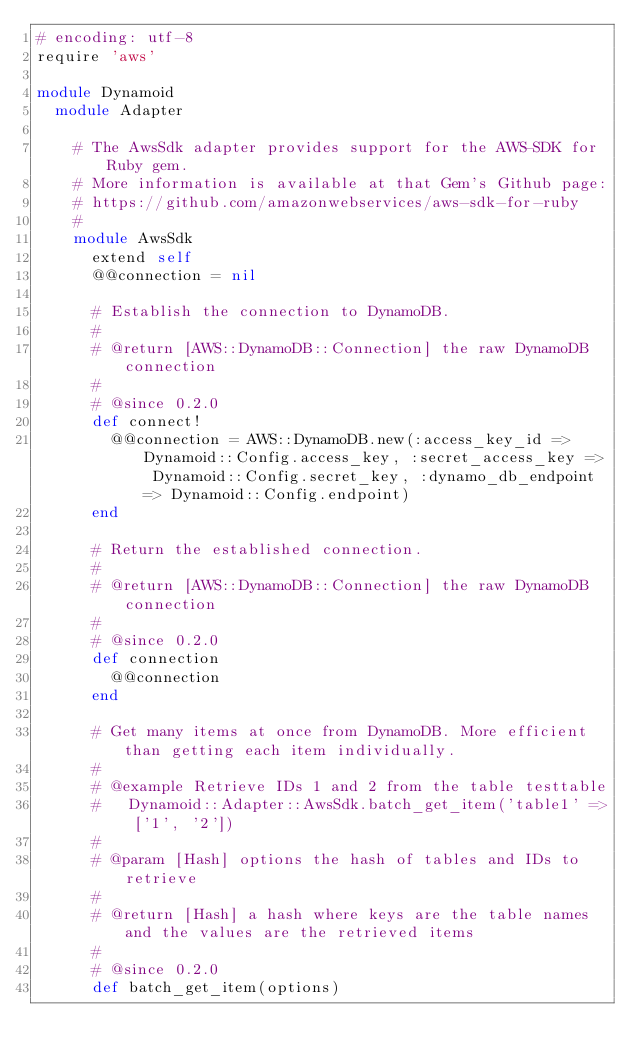<code> <loc_0><loc_0><loc_500><loc_500><_Ruby_># encoding: utf-8
require 'aws'

module Dynamoid
  module Adapter
    
    # The AwsSdk adapter provides support for the AWS-SDK for Ruby gem.
    # More information is available at that Gem's Github page:
    # https://github.com/amazonwebservices/aws-sdk-for-ruby
    # 
    module AwsSdk
      extend self
      @@connection = nil
    
      # Establish the connection to DynamoDB.
      #
      # @return [AWS::DynamoDB::Connection] the raw DynamoDB connection
      #
      # @since 0.2.0
      def connect!
        @@connection = AWS::DynamoDB.new(:access_key_id => Dynamoid::Config.access_key, :secret_access_key => Dynamoid::Config.secret_key, :dynamo_db_endpoint => Dynamoid::Config.endpoint)
      end
    
      # Return the established connection.
      #
      # @return [AWS::DynamoDB::Connection] the raw DynamoDB connection
      #
      # @since 0.2.0
      def connection
        @@connection
      end
    
      # Get many items at once from DynamoDB. More efficient than getting each item individually.
      # 
      # @example Retrieve IDs 1 and 2 from the table testtable
      #   Dynamoid::Adapter::AwsSdk.batch_get_item('table1' => ['1', '2'])
      #
      # @param [Hash] options the hash of tables and IDs to retrieve
      #
      # @return [Hash] a hash where keys are the table names and the values are the retrieved items
      # 
      # @since 0.2.0
      def batch_get_item(options)</code> 